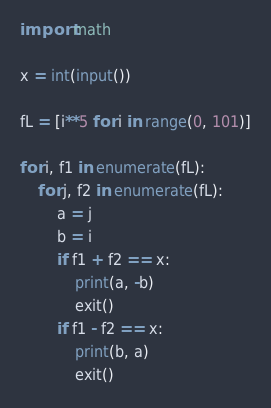<code> <loc_0><loc_0><loc_500><loc_500><_Python_>import math

x = int(input())

fL = [i**5 for i in range(0, 101)]

for i, f1 in enumerate(fL):
    for j, f2 in enumerate(fL):
        a = j
        b = i
        if f1 + f2 == x:
            print(a, -b)
            exit()
        if f1 - f2 == x:
            print(b, a)
            exit()
</code> 